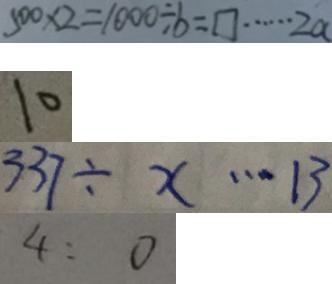Convert formula to latex. <formula><loc_0><loc_0><loc_500><loc_500>5 0 0 \times 2 = 1 0 0 0 \div b = \square \cdots 2 a 
 1 0 
 3 3 7 \div x \cdots 1 3 
 4 : 0</formula> 